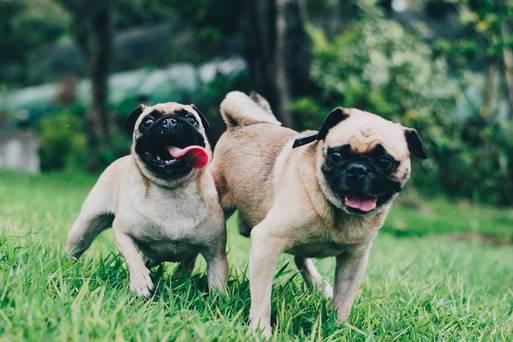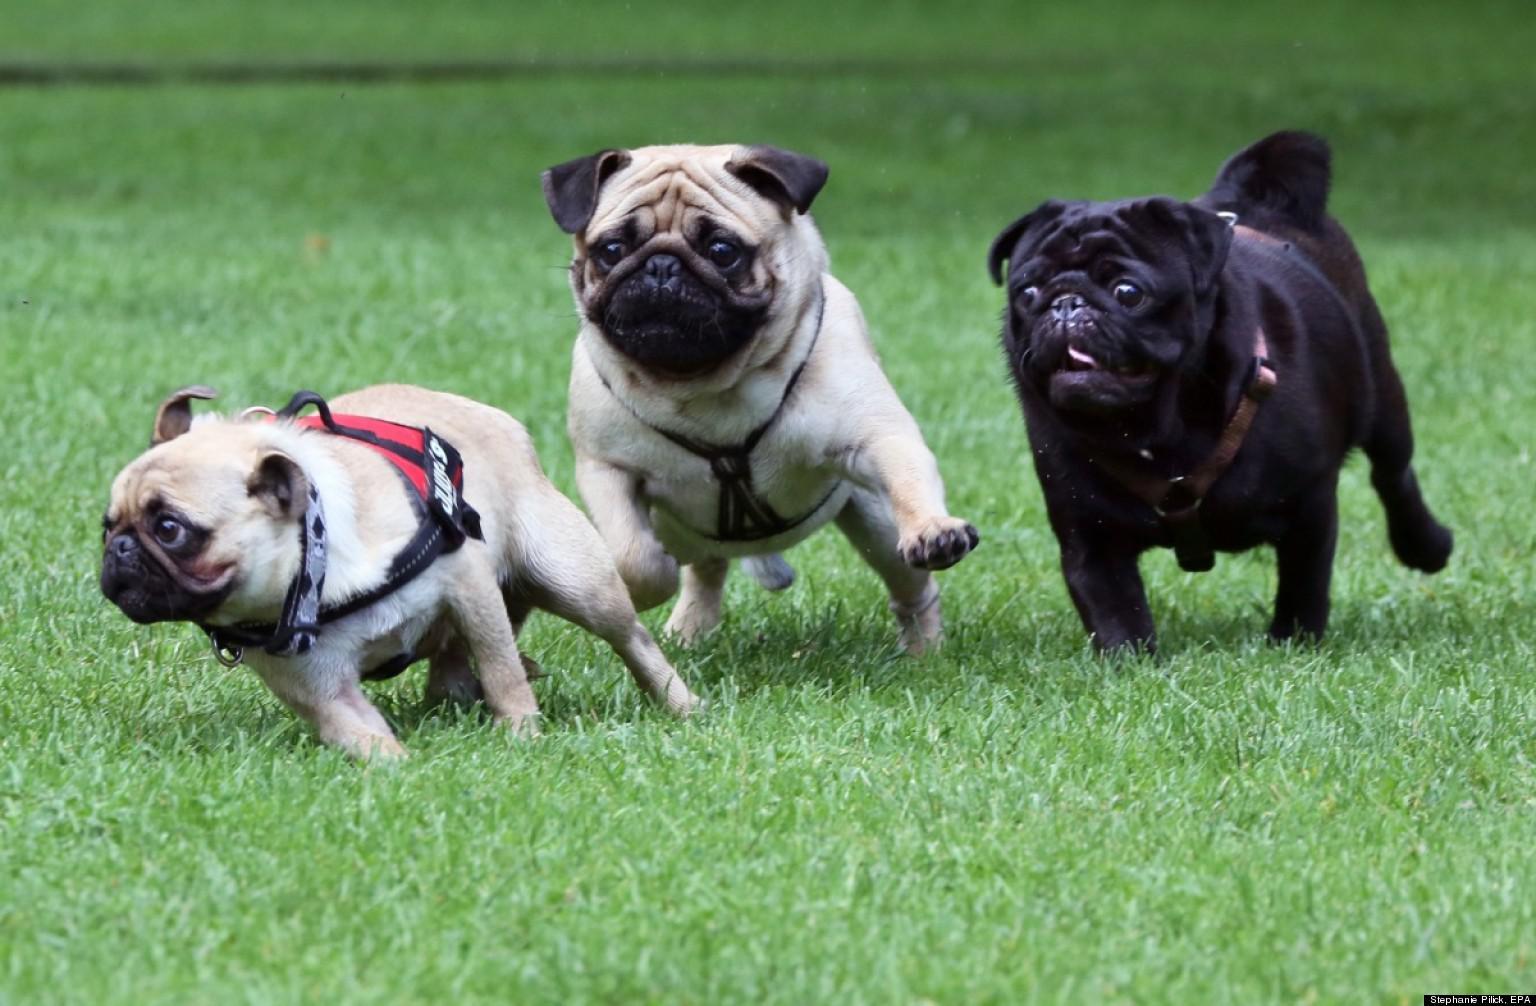The first image is the image on the left, the second image is the image on the right. Analyze the images presented: Is the assertion "An image shows one pug with a toy ball of some type." valid? Answer yes or no. No. The first image is the image on the left, the second image is the image on the right. Considering the images on both sides, is "There is no more than one dog in the left image." valid? Answer yes or no. No. 